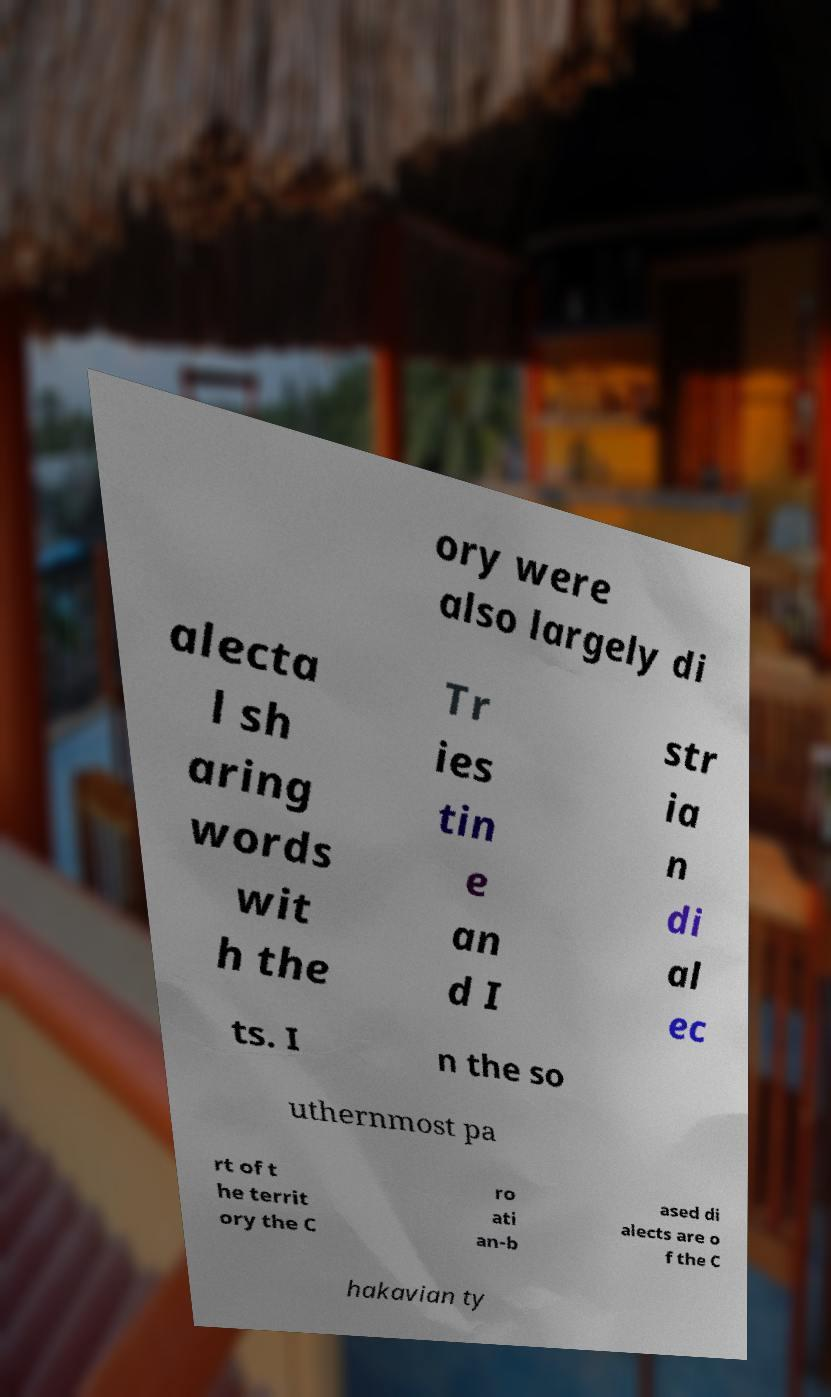There's text embedded in this image that I need extracted. Can you transcribe it verbatim? ory were also largely di alecta l sh aring words wit h the Tr ies tin e an d I str ia n di al ec ts. I n the so uthernmost pa rt of t he territ ory the C ro ati an-b ased di alects are o f the C hakavian ty 